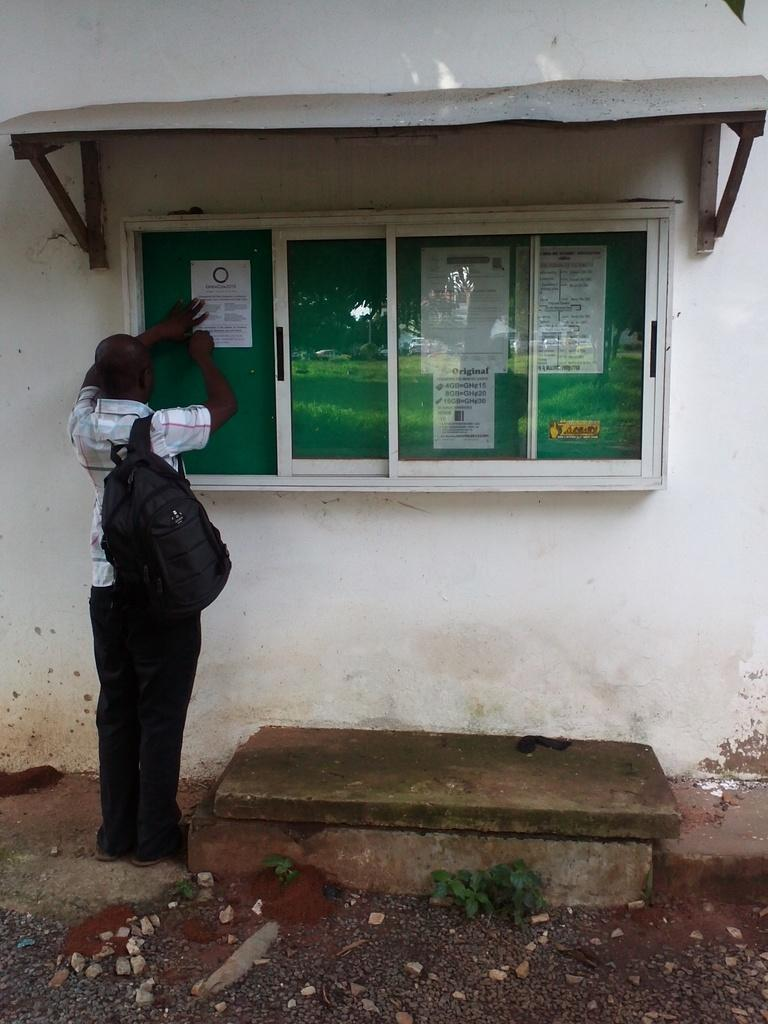What type of living organisms can be seen in the image? Plants are visible in the image. What can be found on the ground in the image? Stones are present on the ground. What is the person in the image carrying? The person in the image is carrying a bag. What type of structure is visible in the image? Posts on a board and a wall are visible in the image. What is used to provide shade in the image? A sun shade is present in the image. Can you describe any other objects in the image? There are some objects in the image, but their specific nature is not mentioned in the provided facts. What type of pain is the person experiencing in the image? There is no indication of pain in the image; the person is simply carrying a bag. What kind of noise can be heard coming from the objects in the image? There is no mention of noise in the image, and the nature of the objects is not specified. 